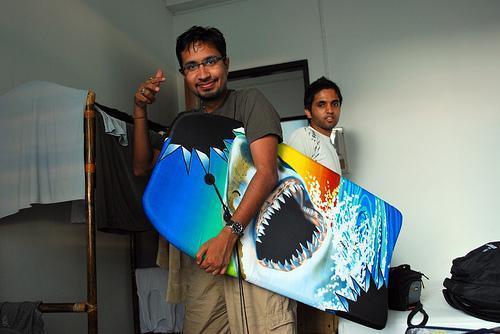How many people are wearing glasses?
Give a very brief answer. 1. How many men are in front of the sharkboard?
Give a very brief answer. 0. 